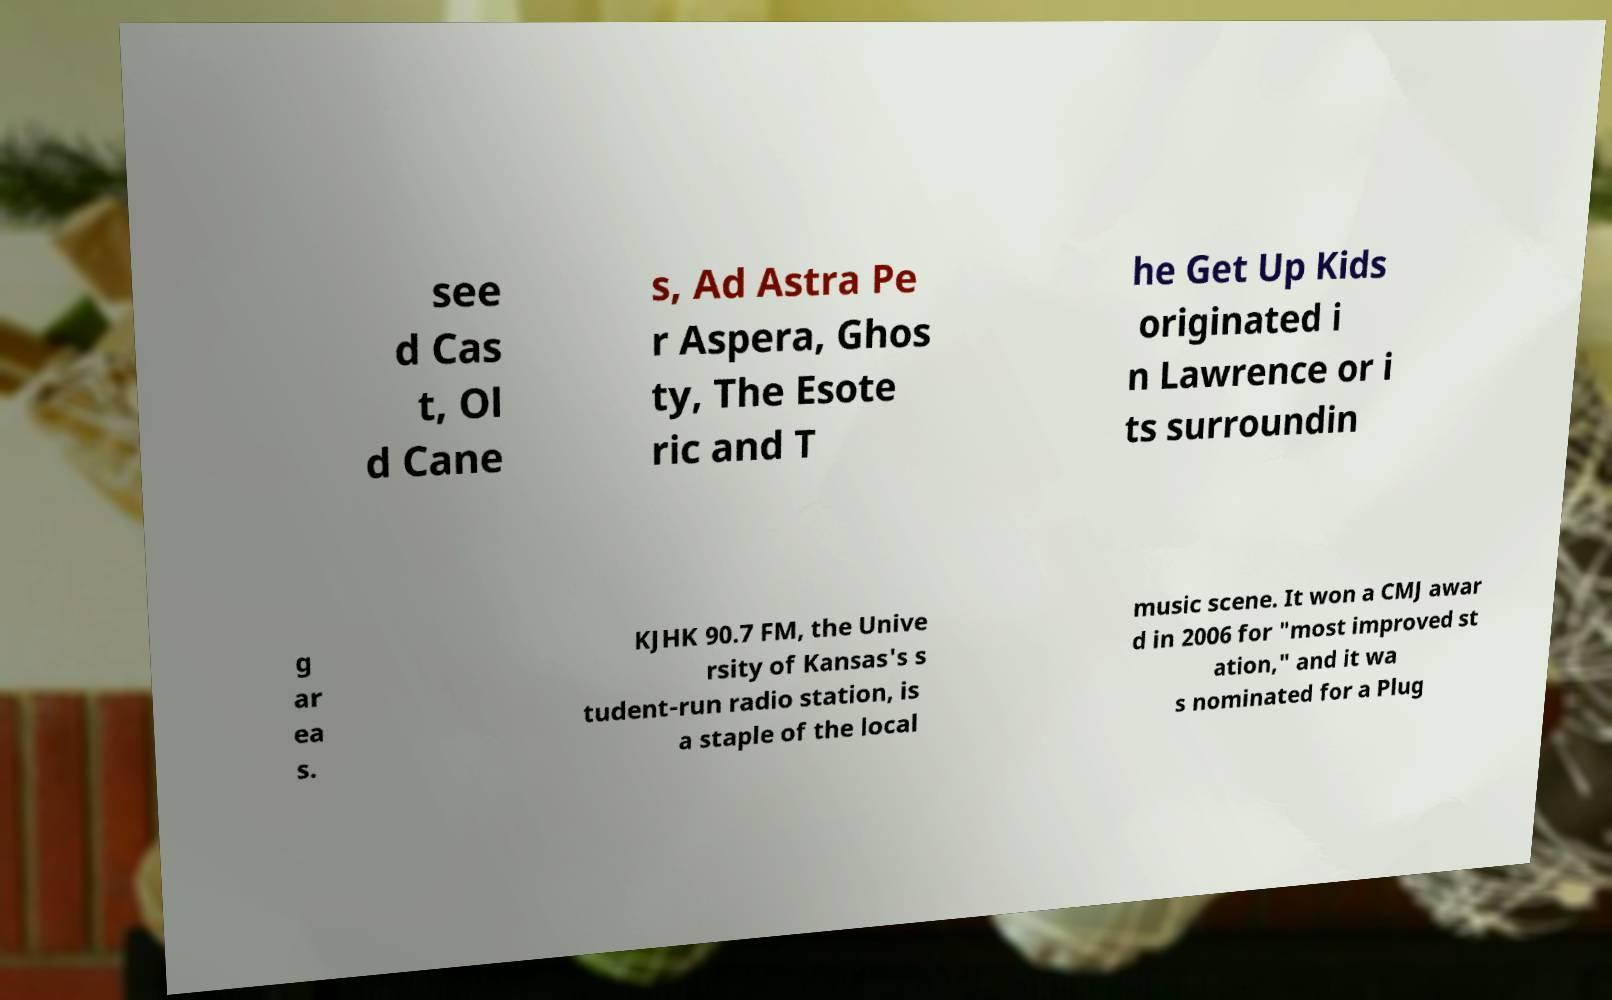Can you read and provide the text displayed in the image?This photo seems to have some interesting text. Can you extract and type it out for me? see d Cas t, Ol d Cane s, Ad Astra Pe r Aspera, Ghos ty, The Esote ric and T he Get Up Kids originated i n Lawrence or i ts surroundin g ar ea s. KJHK 90.7 FM, the Unive rsity of Kansas's s tudent-run radio station, is a staple of the local music scene. It won a CMJ awar d in 2006 for "most improved st ation," and it wa s nominated for a Plug 